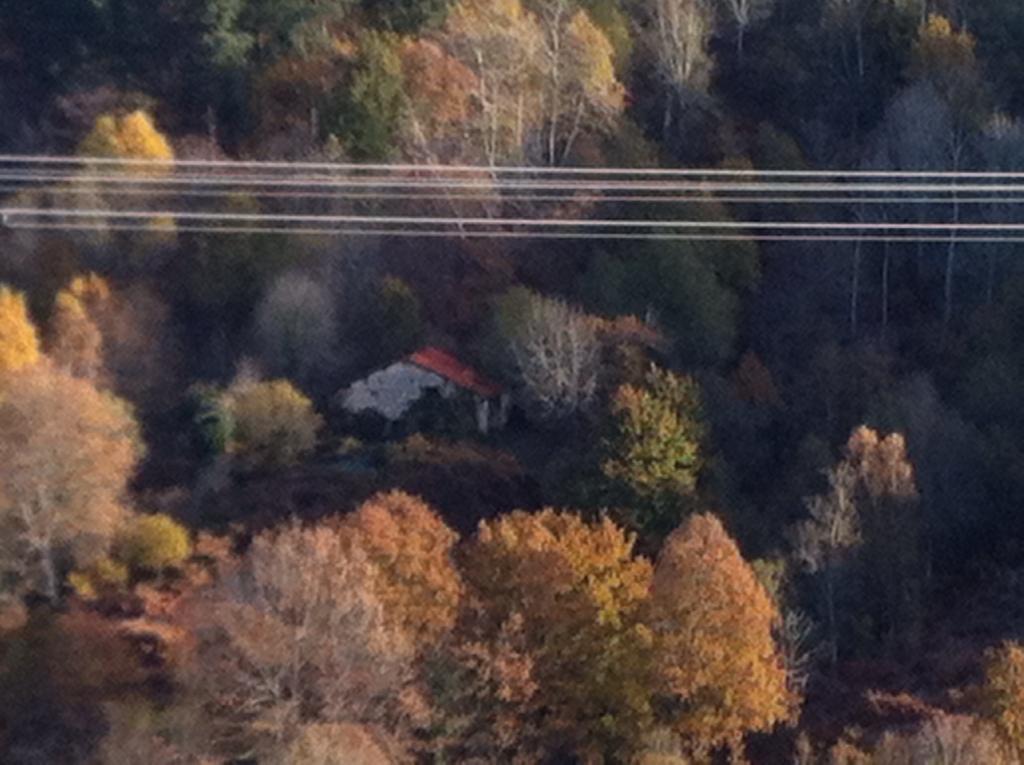How would you summarize this image in a sentence or two? In this picture we can see a few trees throughout the image. There is a house. We can see some wires on top from left to right. 